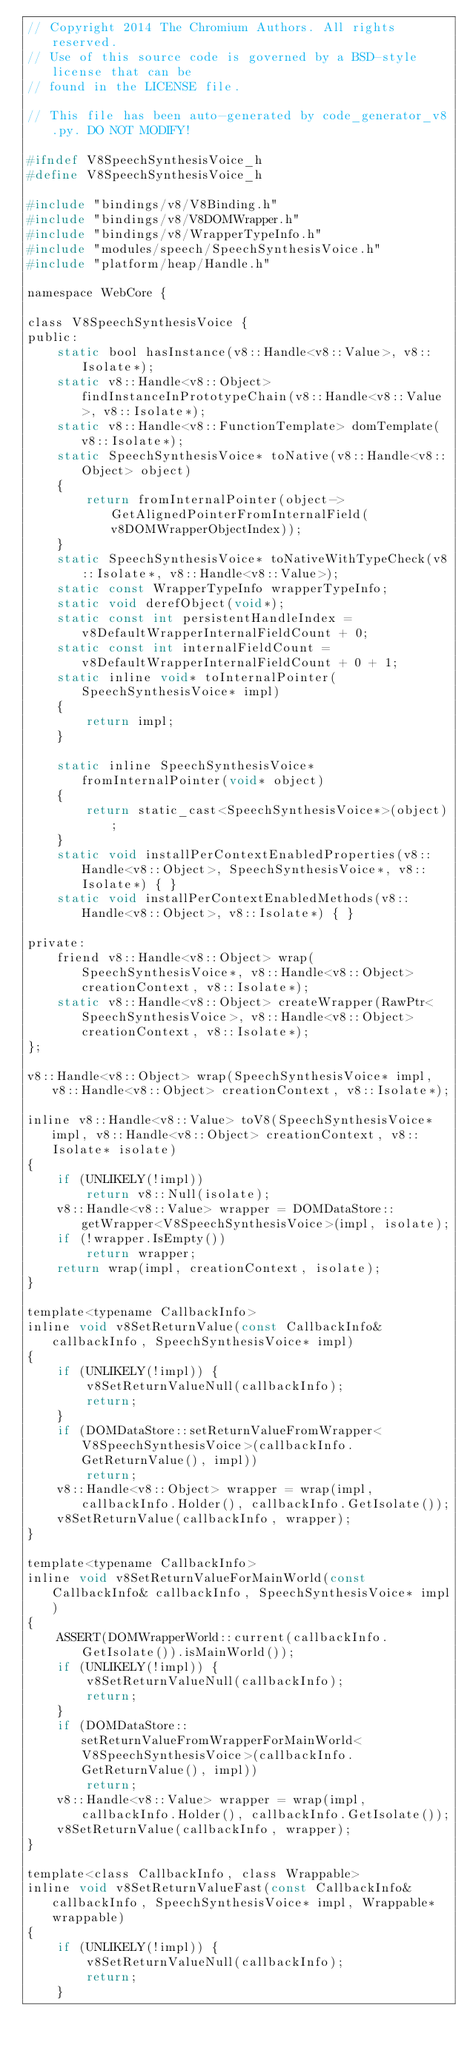<code> <loc_0><loc_0><loc_500><loc_500><_C_>// Copyright 2014 The Chromium Authors. All rights reserved.
// Use of this source code is governed by a BSD-style license that can be
// found in the LICENSE file.

// This file has been auto-generated by code_generator_v8.py. DO NOT MODIFY!

#ifndef V8SpeechSynthesisVoice_h
#define V8SpeechSynthesisVoice_h

#include "bindings/v8/V8Binding.h"
#include "bindings/v8/V8DOMWrapper.h"
#include "bindings/v8/WrapperTypeInfo.h"
#include "modules/speech/SpeechSynthesisVoice.h"
#include "platform/heap/Handle.h"

namespace WebCore {

class V8SpeechSynthesisVoice {
public:
    static bool hasInstance(v8::Handle<v8::Value>, v8::Isolate*);
    static v8::Handle<v8::Object> findInstanceInPrototypeChain(v8::Handle<v8::Value>, v8::Isolate*);
    static v8::Handle<v8::FunctionTemplate> domTemplate(v8::Isolate*);
    static SpeechSynthesisVoice* toNative(v8::Handle<v8::Object> object)
    {
        return fromInternalPointer(object->GetAlignedPointerFromInternalField(v8DOMWrapperObjectIndex));
    }
    static SpeechSynthesisVoice* toNativeWithTypeCheck(v8::Isolate*, v8::Handle<v8::Value>);
    static const WrapperTypeInfo wrapperTypeInfo;
    static void derefObject(void*);
    static const int persistentHandleIndex = v8DefaultWrapperInternalFieldCount + 0;
    static const int internalFieldCount = v8DefaultWrapperInternalFieldCount + 0 + 1;
    static inline void* toInternalPointer(SpeechSynthesisVoice* impl)
    {
        return impl;
    }

    static inline SpeechSynthesisVoice* fromInternalPointer(void* object)
    {
        return static_cast<SpeechSynthesisVoice*>(object);
    }
    static void installPerContextEnabledProperties(v8::Handle<v8::Object>, SpeechSynthesisVoice*, v8::Isolate*) { }
    static void installPerContextEnabledMethods(v8::Handle<v8::Object>, v8::Isolate*) { }

private:
    friend v8::Handle<v8::Object> wrap(SpeechSynthesisVoice*, v8::Handle<v8::Object> creationContext, v8::Isolate*);
    static v8::Handle<v8::Object> createWrapper(RawPtr<SpeechSynthesisVoice>, v8::Handle<v8::Object> creationContext, v8::Isolate*);
};

v8::Handle<v8::Object> wrap(SpeechSynthesisVoice* impl, v8::Handle<v8::Object> creationContext, v8::Isolate*);

inline v8::Handle<v8::Value> toV8(SpeechSynthesisVoice* impl, v8::Handle<v8::Object> creationContext, v8::Isolate* isolate)
{
    if (UNLIKELY(!impl))
        return v8::Null(isolate);
    v8::Handle<v8::Value> wrapper = DOMDataStore::getWrapper<V8SpeechSynthesisVoice>(impl, isolate);
    if (!wrapper.IsEmpty())
        return wrapper;
    return wrap(impl, creationContext, isolate);
}

template<typename CallbackInfo>
inline void v8SetReturnValue(const CallbackInfo& callbackInfo, SpeechSynthesisVoice* impl)
{
    if (UNLIKELY(!impl)) {
        v8SetReturnValueNull(callbackInfo);
        return;
    }
    if (DOMDataStore::setReturnValueFromWrapper<V8SpeechSynthesisVoice>(callbackInfo.GetReturnValue(), impl))
        return;
    v8::Handle<v8::Object> wrapper = wrap(impl, callbackInfo.Holder(), callbackInfo.GetIsolate());
    v8SetReturnValue(callbackInfo, wrapper);
}

template<typename CallbackInfo>
inline void v8SetReturnValueForMainWorld(const CallbackInfo& callbackInfo, SpeechSynthesisVoice* impl)
{
    ASSERT(DOMWrapperWorld::current(callbackInfo.GetIsolate()).isMainWorld());
    if (UNLIKELY(!impl)) {
        v8SetReturnValueNull(callbackInfo);
        return;
    }
    if (DOMDataStore::setReturnValueFromWrapperForMainWorld<V8SpeechSynthesisVoice>(callbackInfo.GetReturnValue(), impl))
        return;
    v8::Handle<v8::Value> wrapper = wrap(impl, callbackInfo.Holder(), callbackInfo.GetIsolate());
    v8SetReturnValue(callbackInfo, wrapper);
}

template<class CallbackInfo, class Wrappable>
inline void v8SetReturnValueFast(const CallbackInfo& callbackInfo, SpeechSynthesisVoice* impl, Wrappable* wrappable)
{
    if (UNLIKELY(!impl)) {
        v8SetReturnValueNull(callbackInfo);
        return;
    }</code> 